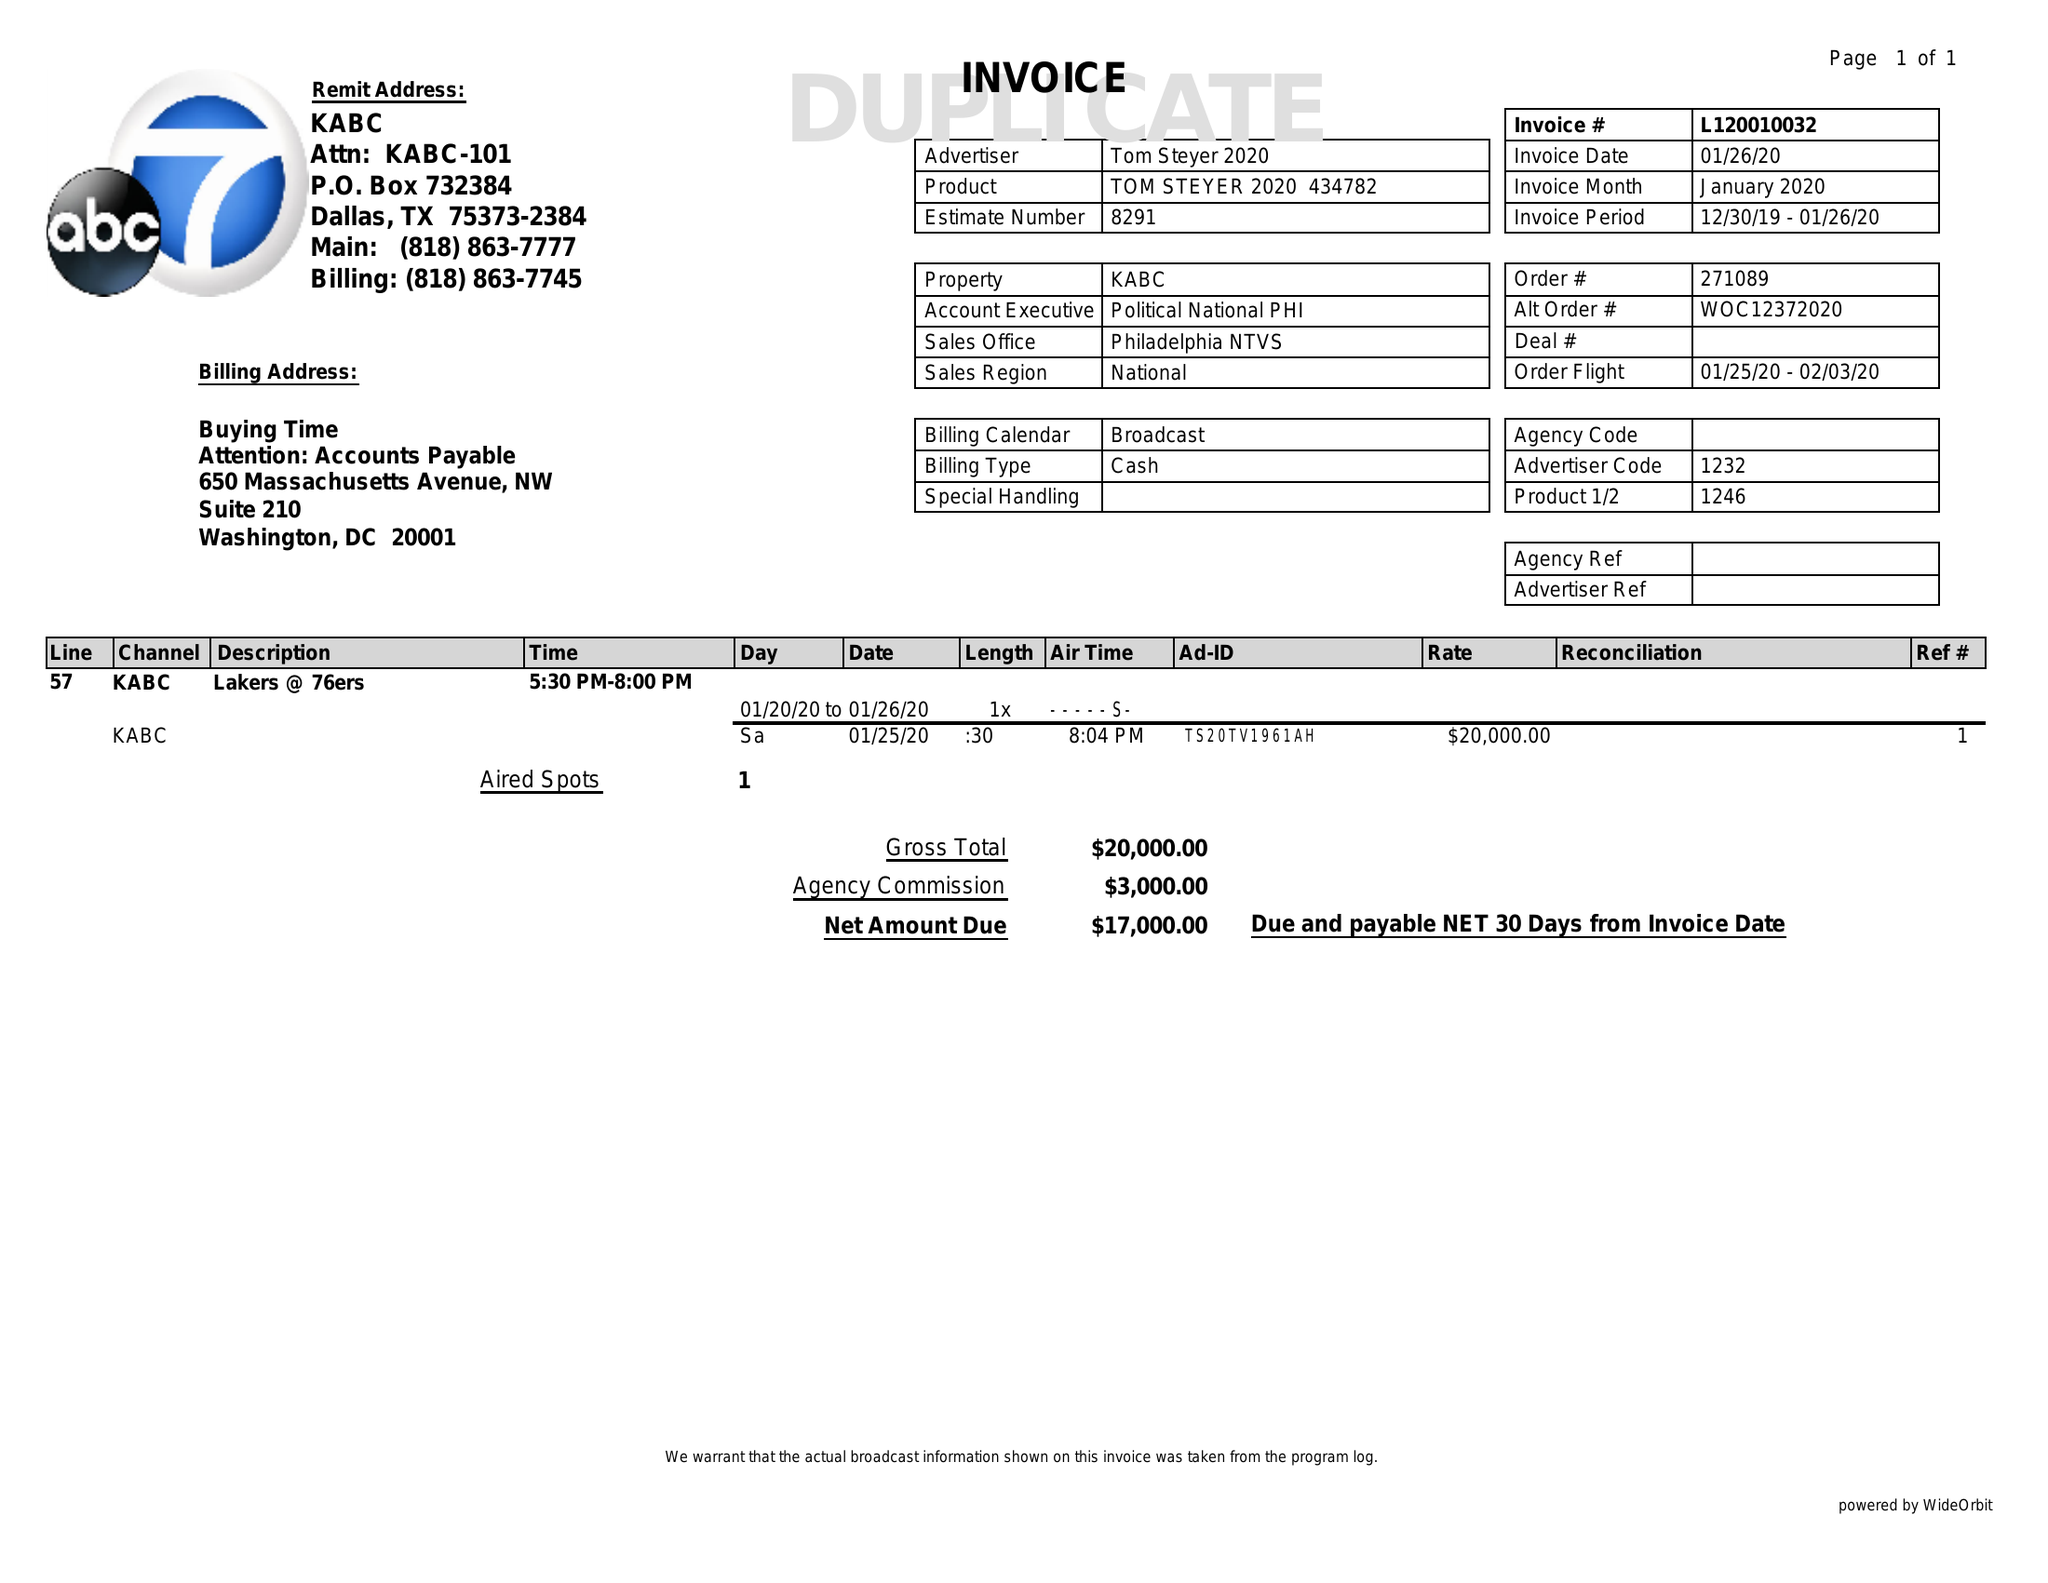What is the value for the contract_num?
Answer the question using a single word or phrase. L120010032 